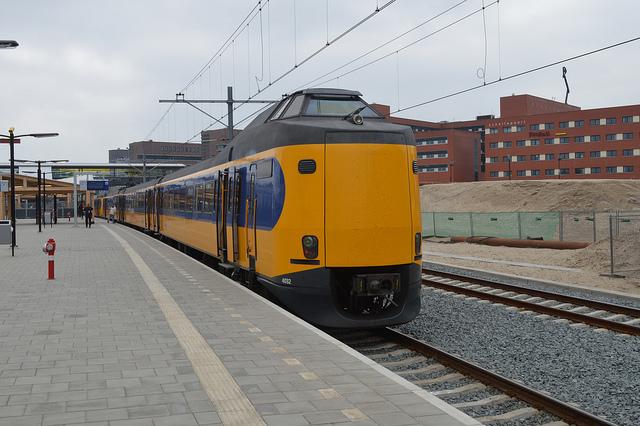How many tracks are seen?
Concise answer only. 2. What is the main color of the train?
Short answer required. Yellow. Are there rocks between the train tracks?
Be succinct. Yes. Is this a freight train?
Be succinct. No. Is there a fire hydrant pictured?
Quick response, please. Yes. What track is the red train at?
Quick response, please. None. What color is the train?
Short answer required. Yellow. 